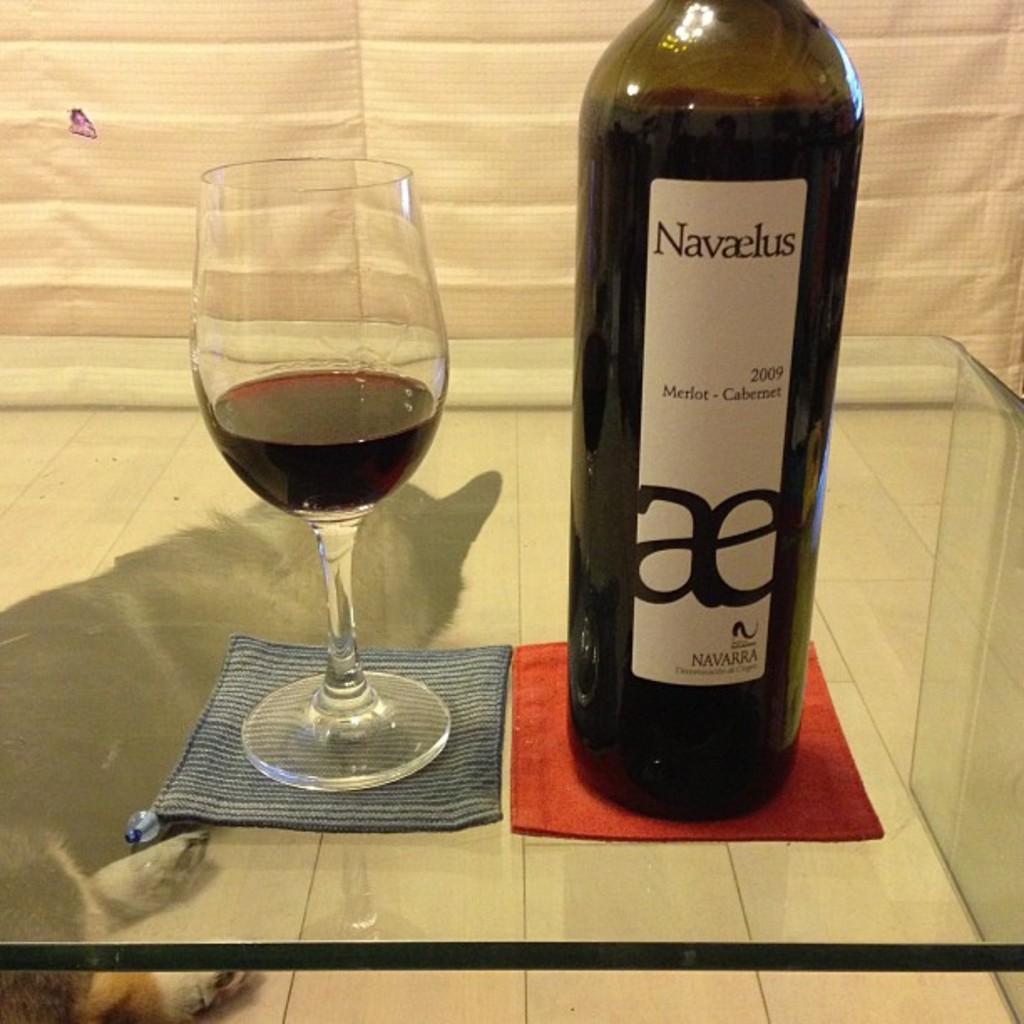Describe this image in one or two sentences. In this image there is a wine glass with a wine , and a wine bottle with a label in a glass table , and in back ground there is a cloth and a animal leg. 